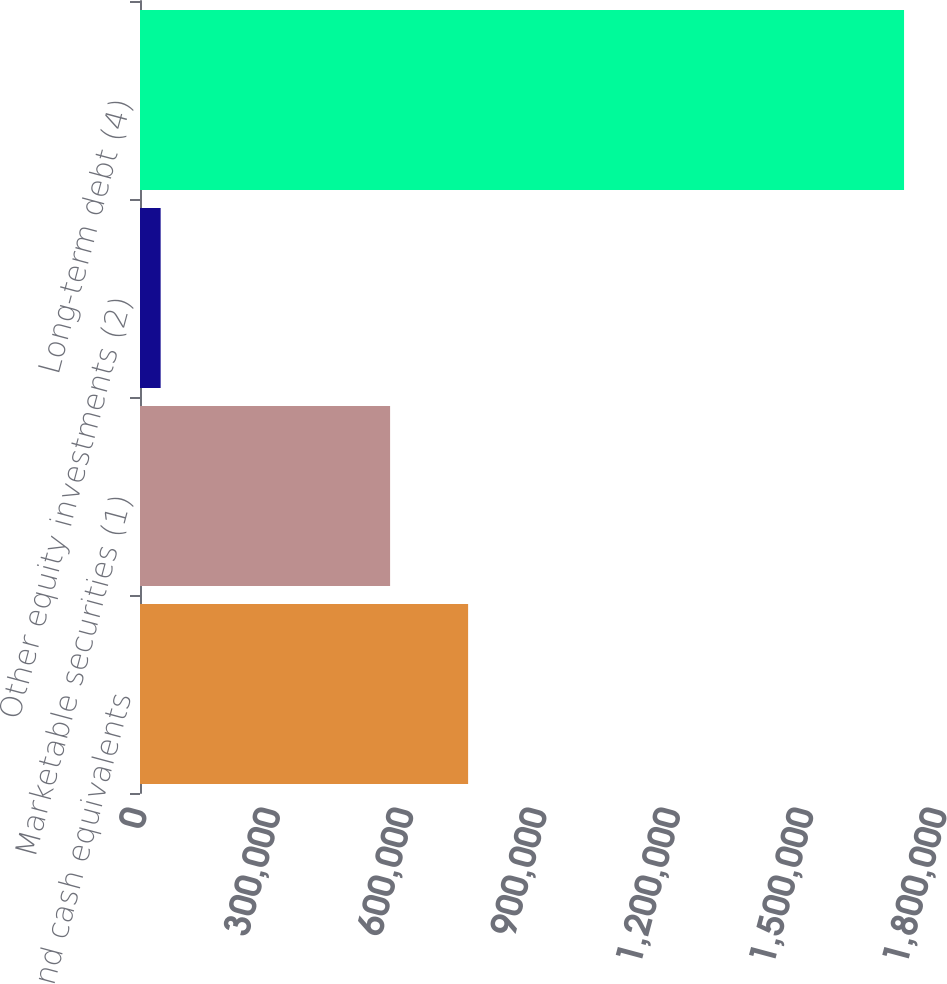Convert chart to OTSL. <chart><loc_0><loc_0><loc_500><loc_500><bar_chart><fcel>Cash and cash equivalents<fcel>Marketable securities (1)<fcel>Other equity investments (2)<fcel>Long-term debt (4)<nl><fcel>738254<fcel>562715<fcel>46454<fcel>1.71911e+06<nl></chart> 